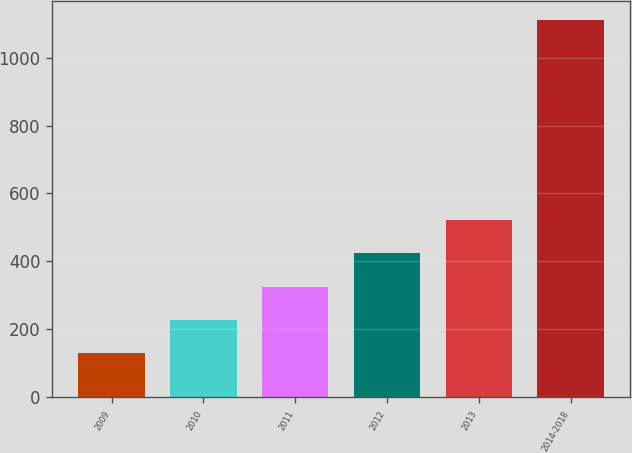<chart> <loc_0><loc_0><loc_500><loc_500><bar_chart><fcel>2009<fcel>2010<fcel>2011<fcel>2012<fcel>2013<fcel>2014-2018<nl><fcel>129<fcel>227.2<fcel>325.4<fcel>423.6<fcel>521.8<fcel>1111<nl></chart> 